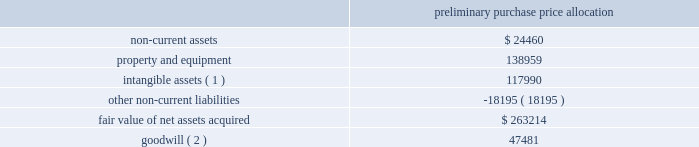American tower corporation and subsidiaries notes to consolidated financial statements the table summarizes the preliminary allocation of the aggregate purchase consideration paid and the amounts of assets acquired and liabilities assumed based upon their estimated fair value at the date of acquisition ( in thousands ) : preliminary purchase price allocation .
( 1 ) consists of customer-related intangibles of approximately $ 80.0 million and network location intangibles of approximately $ 38.0 million .
The customer-related intangibles and network location intangibles are being amortized on a straight-line basis over periods of up to 20 years .
( 2 ) the company expects that the goodwill recorded will be deductible for tax purposes .
The goodwill was allocated to the company 2019s international rental and management segment .
Ghana acquisition 2014on december 6 , 2010 , the company entered into a definitive agreement with mtn group limited ( 201cmtn group 201d ) to establish a joint venture in ghana .
The joint venture is controlled by a holding company of which a wholly owned subsidiary of the company ( the 201catc ghana subsidiary 201d ) holds a 51% ( 51 % ) interest and mobile telephone networks ( netherlands ) b.v. , a wholly owned subsidiary of mtn group ( the 201cmtn ghana subsidiary 201d ) holds a 49% ( 49 % ) interest .
The joint venture is managed and controlled by the company and owns a tower operations company in ghana .
Pursuant to the agreement , on may 6 , 2011 , august 11 , 2011 and december 23 , 2011 , the joint venture acquired 400 , 770 and 686 communications sites , respectively , from mtn group 2019s operating subsidiary in ghana for an aggregate purchase price of $ 515.6 million ( including contingent consideration of $ 2.3 million and value added tax of $ 65.6 million ) .
The aggregate purchase price was subsequently increased to $ 517.7 million ( including contingent consideration of $ 2.3 million and value added tax of $ 65.6 million ) after certain post-closing adjustments .
Under the terms of the purchase agreement , legal title to certain of the communications sites acquired on december 23 , 2011 will be transferred upon fulfillment of certain conditions by mtn group .
Prior to the fulfillment of these conditions , the company will operate and maintain control of these communications sites , and accordingly , reflect these sites in the allocation of purchase price and the consolidated operating results .
In december 2011 , the company signed an amendment to its agreement with mtn group , which requires the company to make additional payments upon the conversion of certain barter agreements with other wireless carriers to cash-paying master lease agreements .
The company currently estimates the fair value of remaining potential contingent consideration payments required to be made under the amended agreement to be between zero and $ 1.0 million and is estimated to be $ 0.9 million using a probability weighted average of the expected outcomes at december 31 , 2012 .
The company has previously made payments under this arrangement of $ 2.6 million .
During the year ended december 31 , 2012 , the company recorded an increase in fair value of $ 0.4 million as other operating expenses in the consolidated statements of operations. .
What was the ratio of the customer-related intangibles to the network location intangibles included in the purchase allocation price? 
Computations: (80.0 / 38.0)
Answer: 2.10526. 